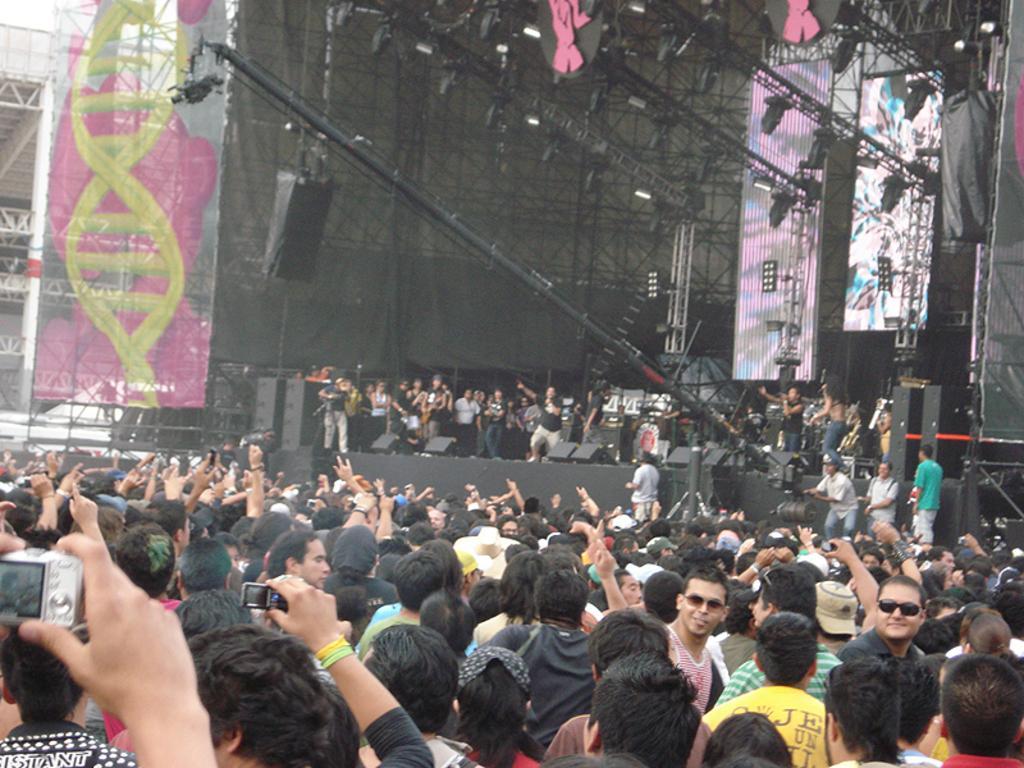Please provide a concise description of this image. This picture shows crowd of people and we see few of them standing on the dais and we see buildings and we see few of them holding cameras in their hands and taking pictures and we see a video camera to the crane and we see speakers on the side and couple of hoardings. 